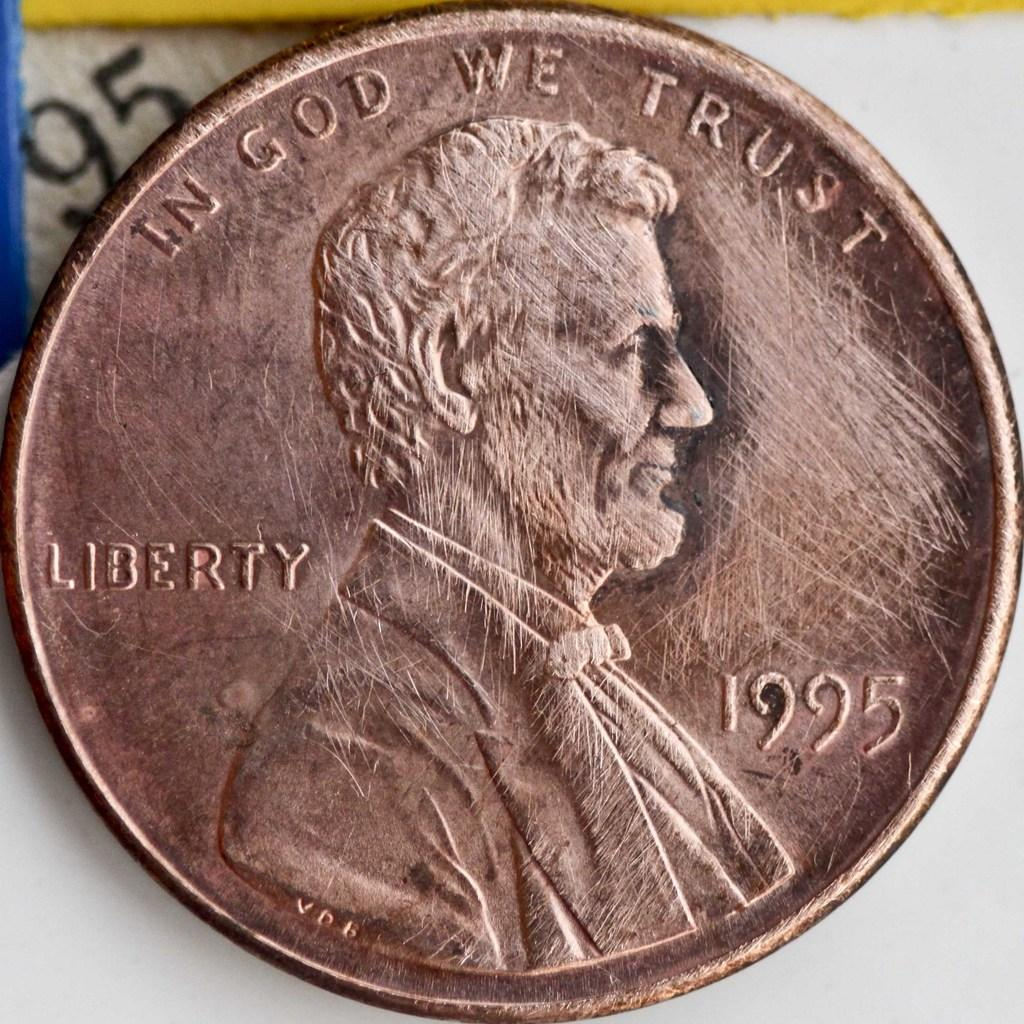<image>
Create a compact narrative representing the image presented. a close up of a copper penny minted in 1995 